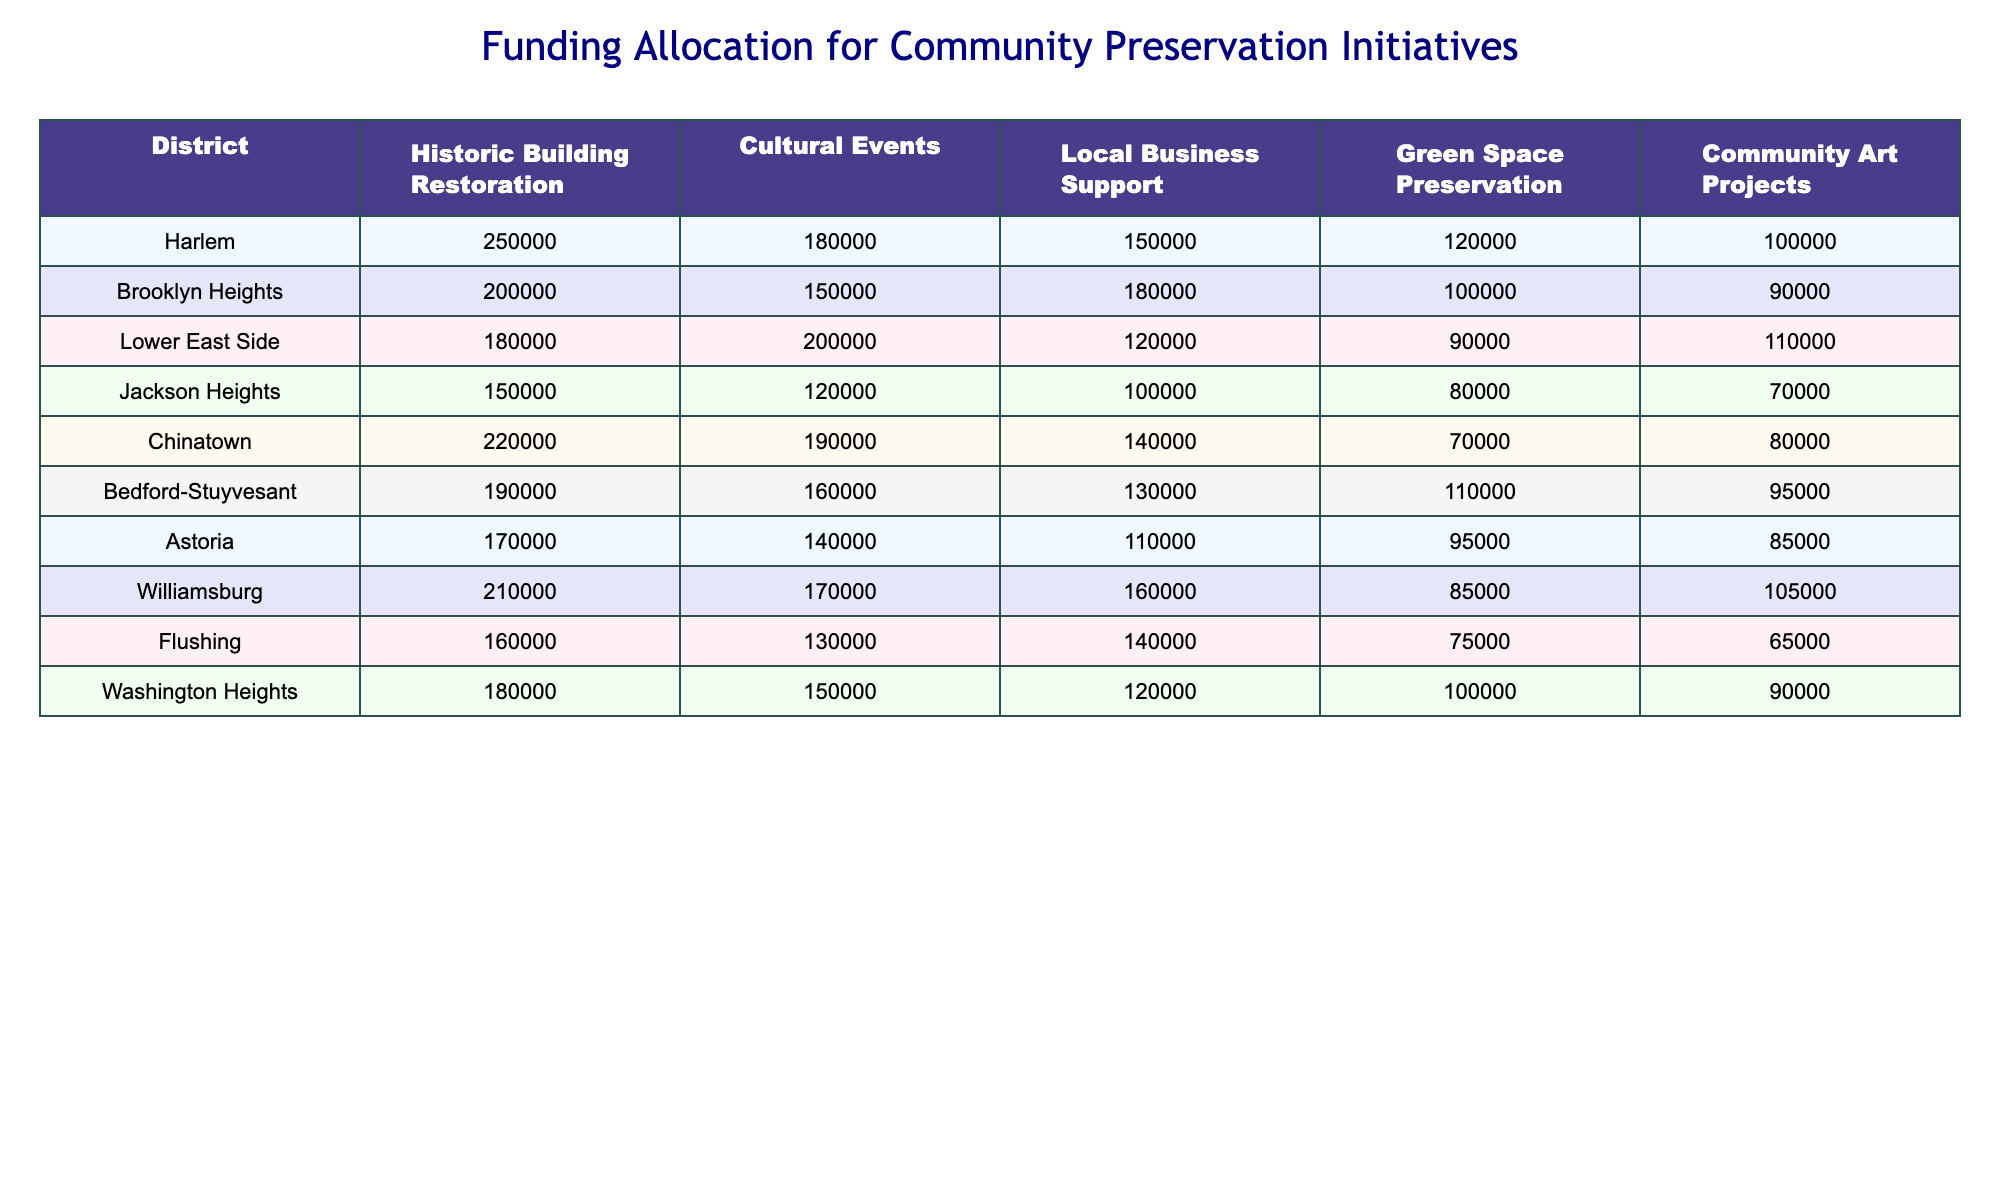What's the total funding for cultural events in Harlem? The funding allocated for cultural events in Harlem is listed as 180,000.
Answer: 180000 Which district received the highest allocation for historic building restoration? By comparing the values in the historic building restoration column, Chinatown has the highest allocation of 220,000.
Answer: Chinatown What is the average funding allocated for community art projects across all districts? Adding up the funding for community art projects gives (100000 + 90000 + 110000 + 70000 + 80000 + 95000 + 85000 + 105000 + 65000 + 90000) = 890000. Dividing by the number of districts (10), the average is 89000.
Answer: 89000 Is there any district that received more than 200,000 for local business support? By examining the local business support row, Bedford-Stuyvesant with 130,000 is the highest, and none exceed 200,000.
Answer: No What is the difference between the highest and lowest funding for green space preservation? The highest funding for green space preservation is 120,000 (Harlem), and the lowest is 70,000 (Chinatown). The difference is 120,000 - 70,000 = 50,000.
Answer: 50000 Which two districts combined received the highest funding for cultural events? The highest values for cultural events are in Lower East Side (200,000) and Chinatown (190,000). Adding these gives 200,000 + 190,000 = 390,000, the highest combined amount.
Answer: 390000 What is the total funding allocated for all projects in Brooklyn Heights? Summing all project types in Brooklyn Heights: 200,000 + 150,000 + 180,000 + 100,000 + 90,000 = 720,000.
Answer: 720000 True or False: Jackson Heights received more funding for community art projects than Harlem. Jackson Heights received 70,000 for community art projects, while Harlem received 100,000, hence the statement is false.
Answer: False If we rank the districts by their total funding for preservation initiatives, where does Astoria stand? Calculating Astoria's total funding: 170,000 + 140,000 + 110,000 + 95,000 + 85,000 = 600,000. By comparing this total with other districts, Astoria ranks fifth overall.
Answer: Fifth What percentage of the total funding for community art projects came from the highest contributing district? The highest contribution for community art projects is from Harlem (100,000). The total for community art projects is 890,000, so the percentage is (100,000 / 890,000) * 100 ≈ 11.24%.
Answer: 11.24% 